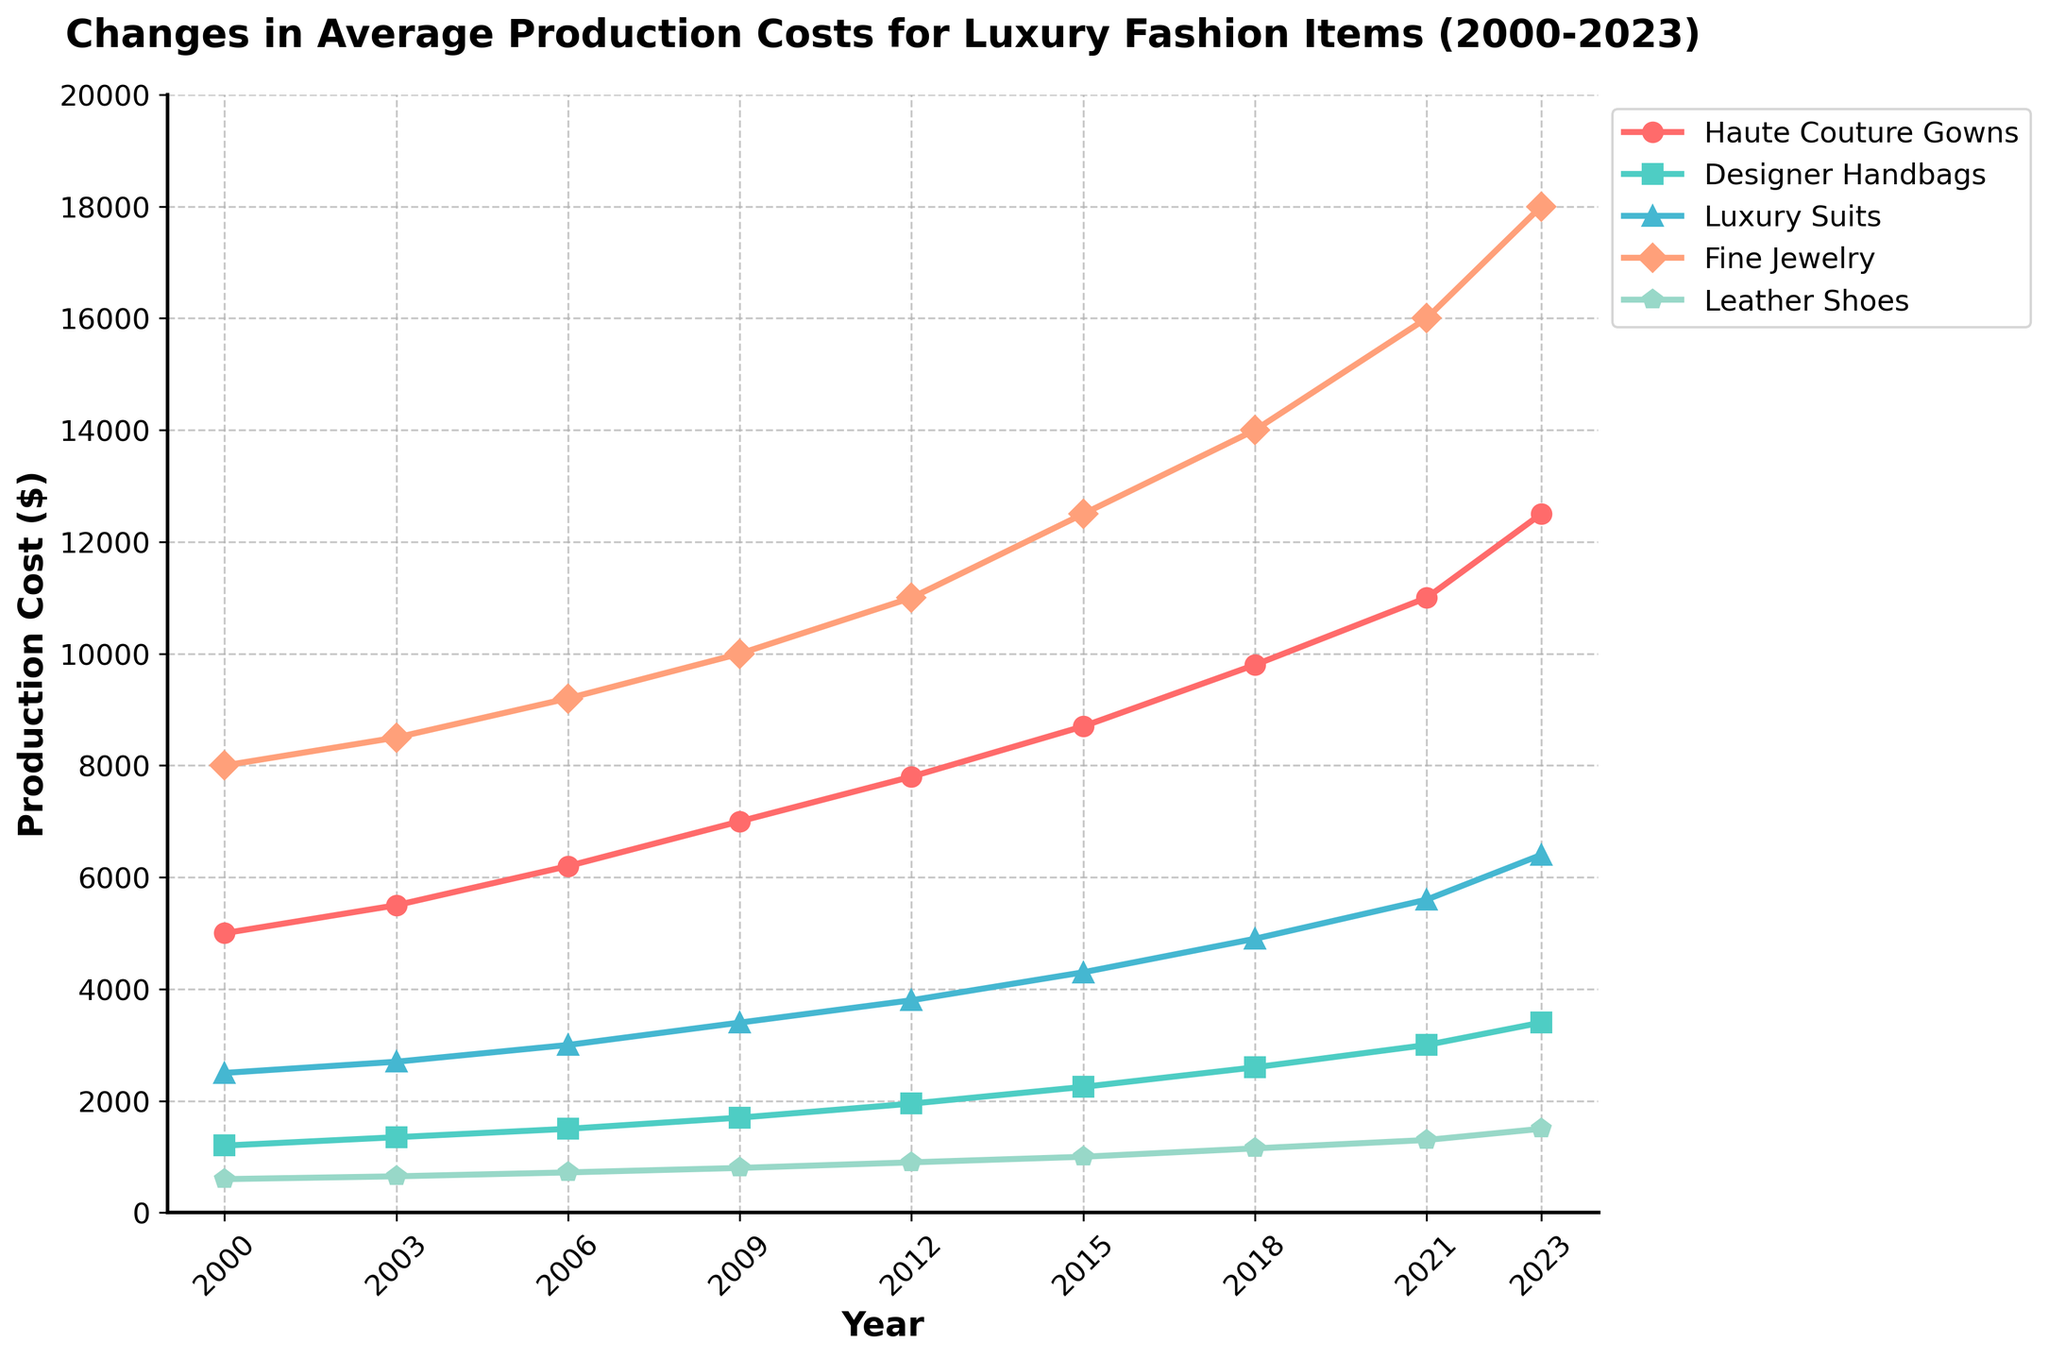What garment type had the highest production cost in 2023? By looking at the line chart, we can identify the garment type by its position on the y-axis in the year 2023. The highest production cost is represented by Fine Jewelry.
Answer: Fine Jewelry What was the production cost difference for Haute Couture Gowns between 2000 and 2023? To find the difference, we subtract the cost in 2000 from the cost in 2023 for Haute Couture Gowns. (12500 - 5000 = 7500)
Answer: 7500 Which garment type had the smallest increase in production cost from 2000 to 2023? Calculate the increase for each garment type by subtracting the 2000 value from the 2023 value. Leather Shoes: (1500 - 600 = 900); compare with others.
Answer: Leather Shoes By how much did the production cost of Leather Shoes increase between 2003 and 2018? Subtract the cost in 2003 from the cost in 2018 for Leather Shoes. (1150 - 650 = 500)
Answer: 500 How does the production cost trend for Fine Jewelry from 2000 to 2023 compare to that for Designer Handbags? Compare the sloping lines for Fine Jewelry and Designer Handbags over the years; Fine Jewelry has a steeper and consistently higher increase.
Answer: Fine Jewelry increases more steeply During which period did the production cost for Luxury Suits experience the most significant growth? By analyzing the sharpness of slopes between periods for Luxury Suits, the largest increase appears between 2018 and 2023.
Answer: 2018-2023 What is the average production cost of Haute Couture Gowns over the years displayed? Sum of the costs over all years divided by the number of data points. (5000 + 5500 + 6200 + 7000 + 7800 + 8700 + 9800 + 11000 + 12500) / 9 = 8166.67
Answer: 8166.67 Compare the production costs of Fine Jewelry and Luxury Suits in 2015. Which one is higher and by how much? Fine Jewelry is 12500, and Luxury Suits are 4300 in 2015. Subtract the Luxury Suits cost from Fine Jewelry. (12500 - 4300 = 8200)
Answer: Fine Jewelry by 8200 What visual trend do you observe for Designer Handbags from 2000 to 2023? The line for Designer Handbags steadily rises from 2000 to 2023, indicating a consistent increase in production cost.
Answer: Consistent increase Which garment type shows the least fluctuation in production cost over the years? By observing the lines' smoothness, Leather Shoes have the least steep and most consistent upward trend.
Answer: Leather Shoes 